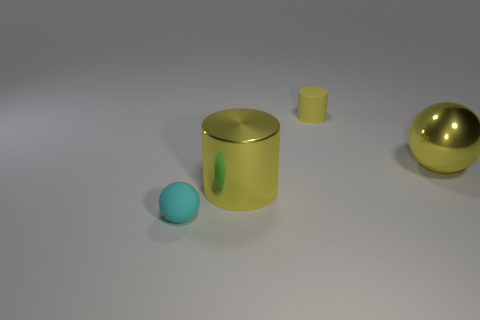Add 2 tiny yellow rubber cylinders. How many objects exist? 6 Add 4 matte cylinders. How many matte cylinders exist? 5 Subtract 0 red balls. How many objects are left? 4 Subtract all cyan cylinders. Subtract all yellow rubber cylinders. How many objects are left? 3 Add 4 cylinders. How many cylinders are left? 6 